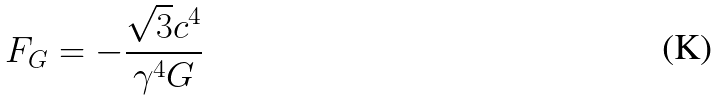Convert formula to latex. <formula><loc_0><loc_0><loc_500><loc_500>F _ { G } = - \frac { \sqrt { 3 } c ^ { 4 } } { \gamma ^ { 4 } G }</formula> 